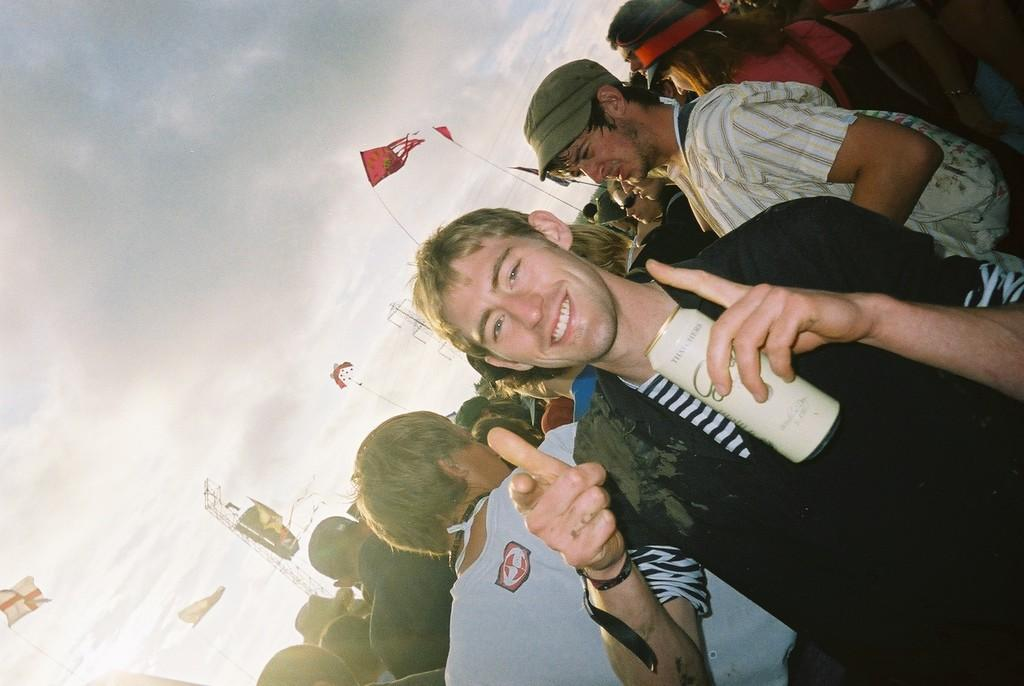How many people are in the image? There is a group of people in the image. What is the man holding in his hand? The man is holding a tin with his hand. What is the man's facial expression? The man is smiling. What can be seen in the background of the image? There are flags, towers, and the sky visible in the background of the image. What type of cast is visible on the elbow of the person in the image? There is no cast visible on any person's elbow in the image. What type of coach is present in the image? There is no coach present in the image. 